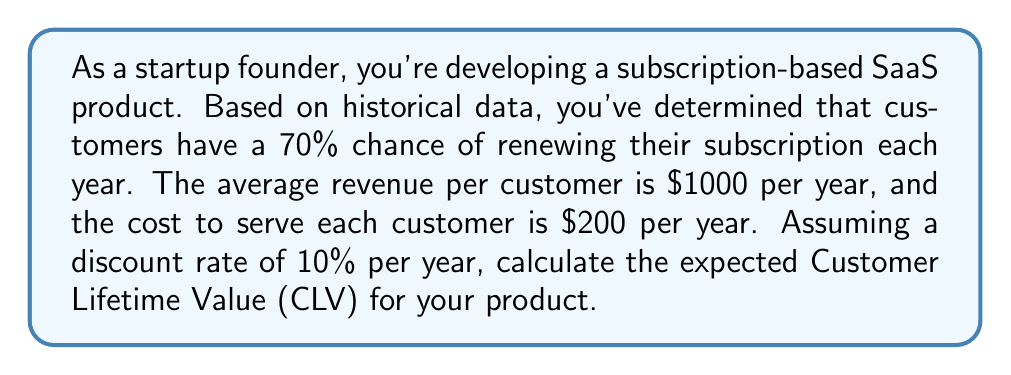Give your solution to this math problem. To calculate the Customer Lifetime Value (CLV) using a probabilistic model, we'll use the following approach:

1. Define the variables:
   $r$ = retention rate = 70% = 0.7
   $R$ = annual revenue per customer = $1000
   $C$ = annual cost to serve per customer = $200
   $d$ = discount rate = 10% = 0.1

2. Calculate the annual profit per customer:
   Annual Profit = Revenue - Cost = $R - C$ = $1000 - $200 = $800

3. Use the formula for CLV with a constant retention rate:

   $$ CLV = \frac{M}{1 - r(1+d)^{-1}} $$

   Where:
   $M$ = Margin (Annual Profit) = $800
   $r$ = retention rate = 0.7
   $d$ = discount rate = 0.1

4. Substitute the values into the formula:

   $$ CLV = \frac{800}{1 - 0.7(1+0.1)^{-1}} $$

5. Simplify:
   $$ CLV = \frac{800}{1 - 0.7(0.909090909)} $$
   $$ CLV = \frac{800}{1 - 0.636363636} $$
   $$ CLV = \frac{800}{0.363636364} $$

6. Calculate the final result:
   $$ CLV = 2200 $$

Therefore, the expected Customer Lifetime Value for your product is $2200.
Answer: $2200 